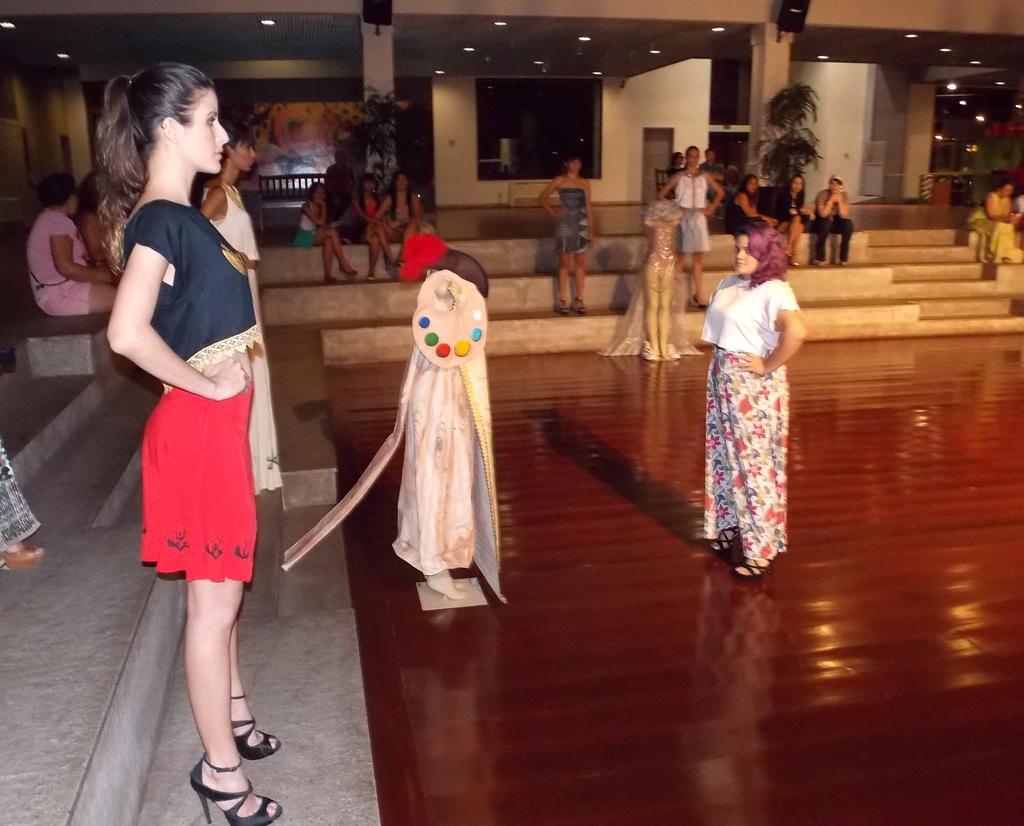In one or two sentences, can you explain what this image depicts? In the picture we can see women models are standing on the steps and behind them, we can see some people are sitting and watching them and near to the steps we can see a wooden floor with women standing with some costumes and in the background we can see some pillars and to the ceiling we can see the lights. 